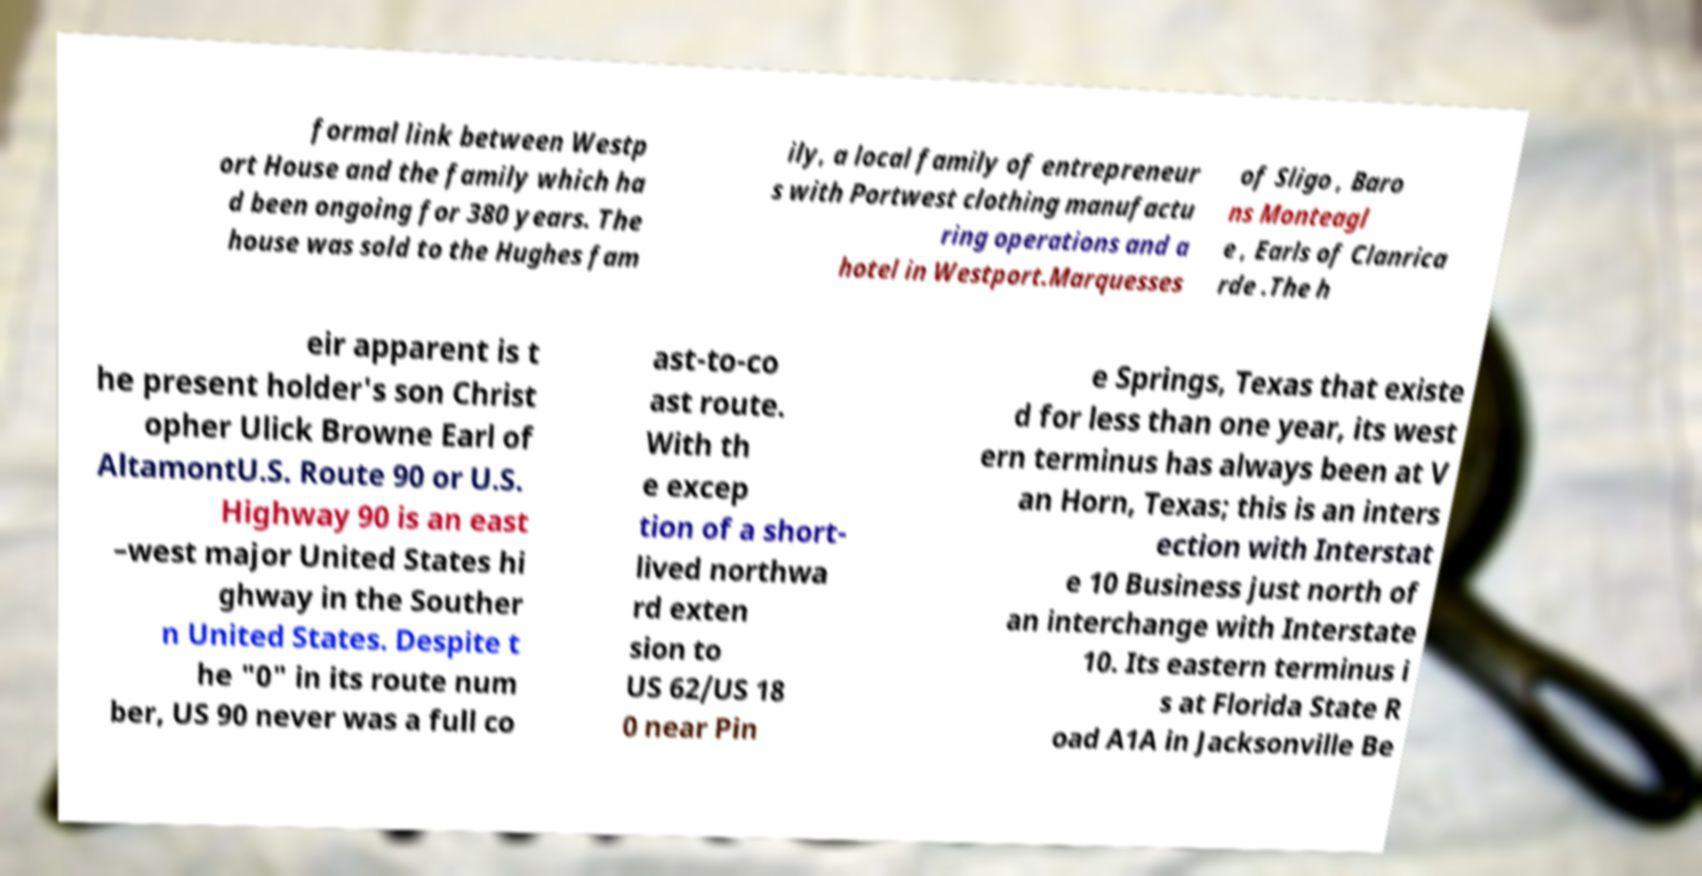Can you read and provide the text displayed in the image?This photo seems to have some interesting text. Can you extract and type it out for me? formal link between Westp ort House and the family which ha d been ongoing for 380 years. The house was sold to the Hughes fam ily, a local family of entrepreneur s with Portwest clothing manufactu ring operations and a hotel in Westport.Marquesses of Sligo , Baro ns Monteagl e , Earls of Clanrica rde .The h eir apparent is t he present holder's son Christ opher Ulick Browne Earl of AltamontU.S. Route 90 or U.S. Highway 90 is an east –west major United States hi ghway in the Souther n United States. Despite t he "0" in its route num ber, US 90 never was a full co ast-to-co ast route. With th e excep tion of a short- lived northwa rd exten sion to US 62/US 18 0 near Pin e Springs, Texas that existe d for less than one year, its west ern terminus has always been at V an Horn, Texas; this is an inters ection with Interstat e 10 Business just north of an interchange with Interstate 10. Its eastern terminus i s at Florida State R oad A1A in Jacksonville Be 